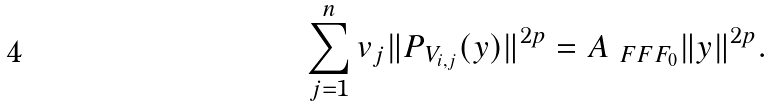<formula> <loc_0><loc_0><loc_500><loc_500>\sum _ { j = 1 } ^ { n } v _ { j } \| P _ { V _ { i , j } } ( y ) \| ^ { 2 p } = A _ { \ F F F _ { 0 } } \| y \| ^ { 2 p } .</formula> 